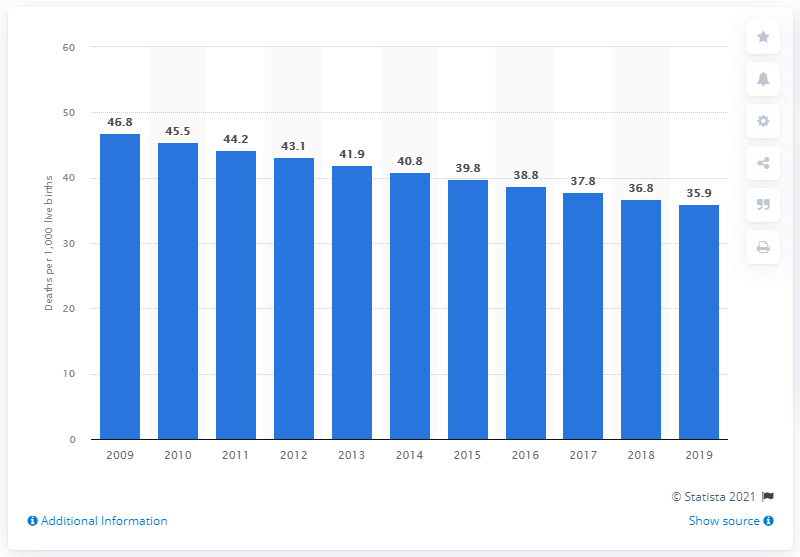List a handful of essential elements in this visual. The infant mortality rate in the Gambia in 2019 was 35.9 deaths per 1,000 live births. 